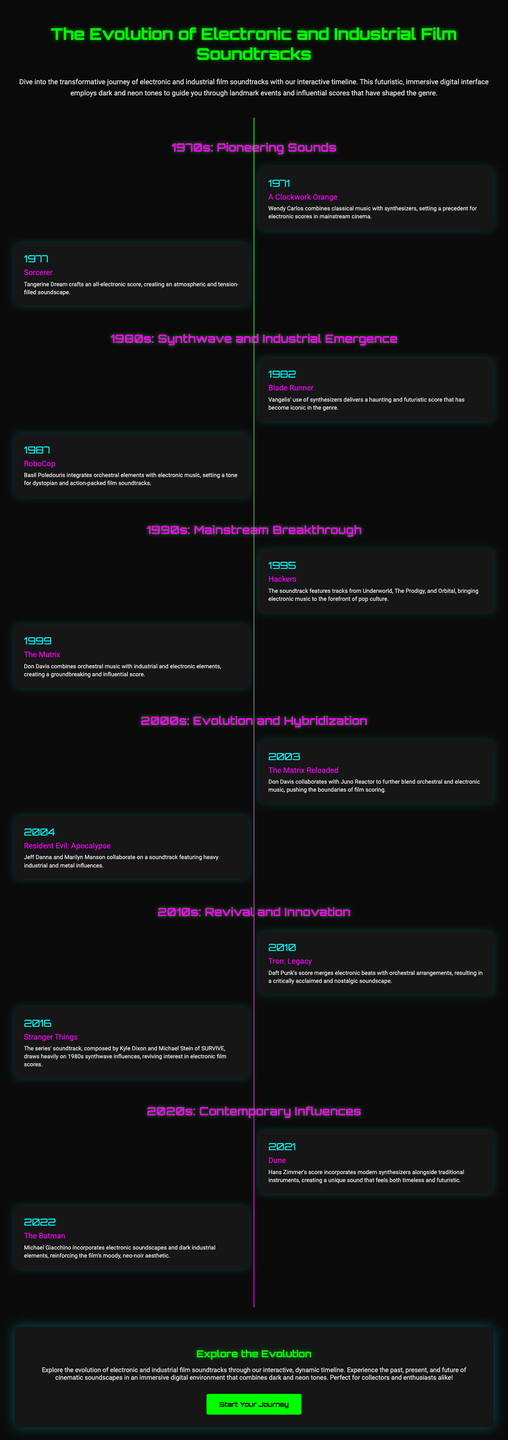What year was "A Clockwork Orange" released? The document states that "A Clockwork Orange" was released in the year 1971.
Answer: 1971 Who composed the score for "Blade Runner"? According to the timeline, the score for "Blade Runner" was composed by Vangelis.
Answer: Vangelis What is the main influence of the score for "Stranger Things"? The document indicates that "Stranger Things" draws heavily on 1980s synthwave influences.
Answer: 1980s synthwave In which decade did electronic scores begin to significantly impact mainstream cinema? The timeline shows that the significant impact of electronic scores began in the 1970s.
Answer: 1970s Which film's score incorporates modern synthesizers alongside traditional instruments? The document mentions "Dune" as the film that incorporates modern synthesizers with traditional instruments.
Answer: Dune What genre is primarily associated with the soundtrack of "RoboCop"? The timeline describes the genre associated with the soundtrack of "RoboCop" as dystopian and action-packed.
Answer: Dystopian and action-packed How does the interface of the timeline blend in terms of color tones? The document states that the interface employs dark and neon tones.
Answer: Dark and neon tones What landmark event occurred in 1995 related to electronic music? In 1995, the soundtrack for "Hackers" featured notable tracks from various electronic music artists.
Answer: Hackers Which two composers collaborated on the score for "Resident Evil: Apocalypse"? The document states that Jeff Danna and Marilyn Manson collaborated on the soundtrack.
Answer: Jeff Danna and Marilyn Manson 